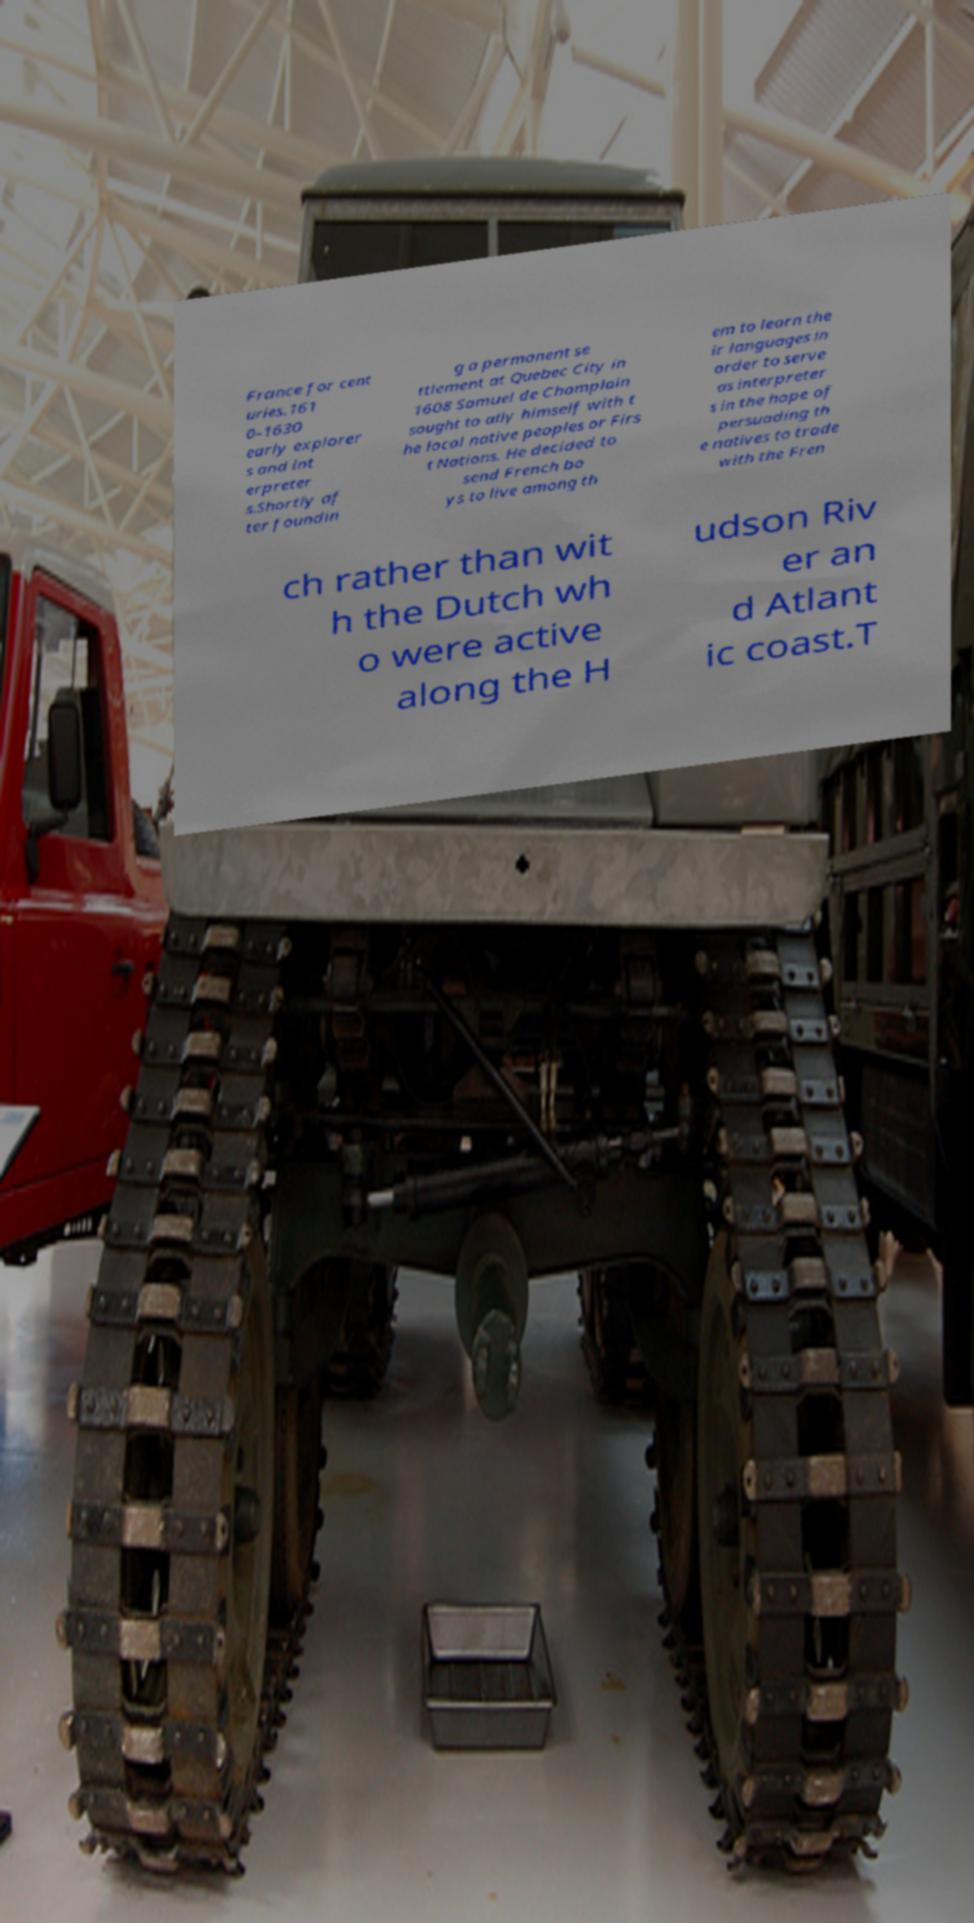Could you assist in decoding the text presented in this image and type it out clearly? France for cent uries.161 0–1630 early explorer s and int erpreter s.Shortly af ter foundin g a permanent se ttlement at Quebec City in 1608 Samuel de Champlain sought to ally himself with t he local native peoples or Firs t Nations. He decided to send French bo ys to live among th em to learn the ir languages in order to serve as interpreter s in the hope of persuading th e natives to trade with the Fren ch rather than wit h the Dutch wh o were active along the H udson Riv er an d Atlant ic coast.T 